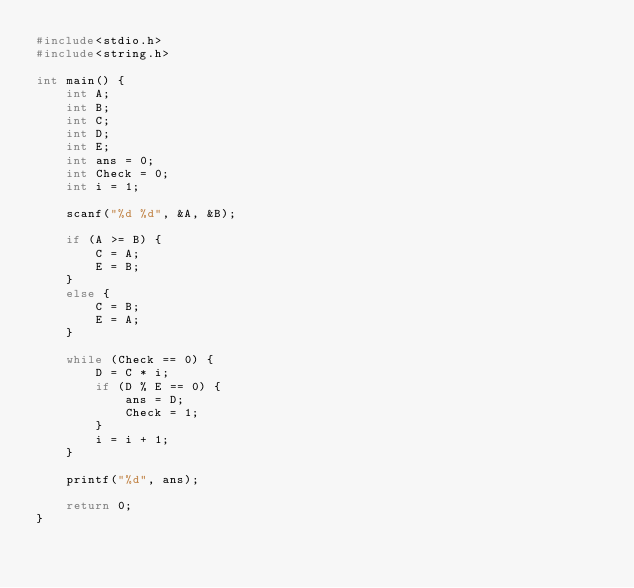<code> <loc_0><loc_0><loc_500><loc_500><_C_>#include<stdio.h>
#include<string.h>

int main() {
	int A;
	int B;
	int C;
	int D;
	int E;
	int ans = 0;
  	int Check = 0;
	int i = 1;

	scanf("%d %d", &A, &B);

	if (A >= B) {
		C = A;
		E = B;
	}
	else {
		C = B;
		E = A;
	}
	
	while (Check == 0) {
		D = C * i;
		if (D % E == 0) {
			ans = D;
          	Check = 1;
		}
		i = i + 1;
	}
	
	printf("%d", ans);

	return 0;
}
</code> 